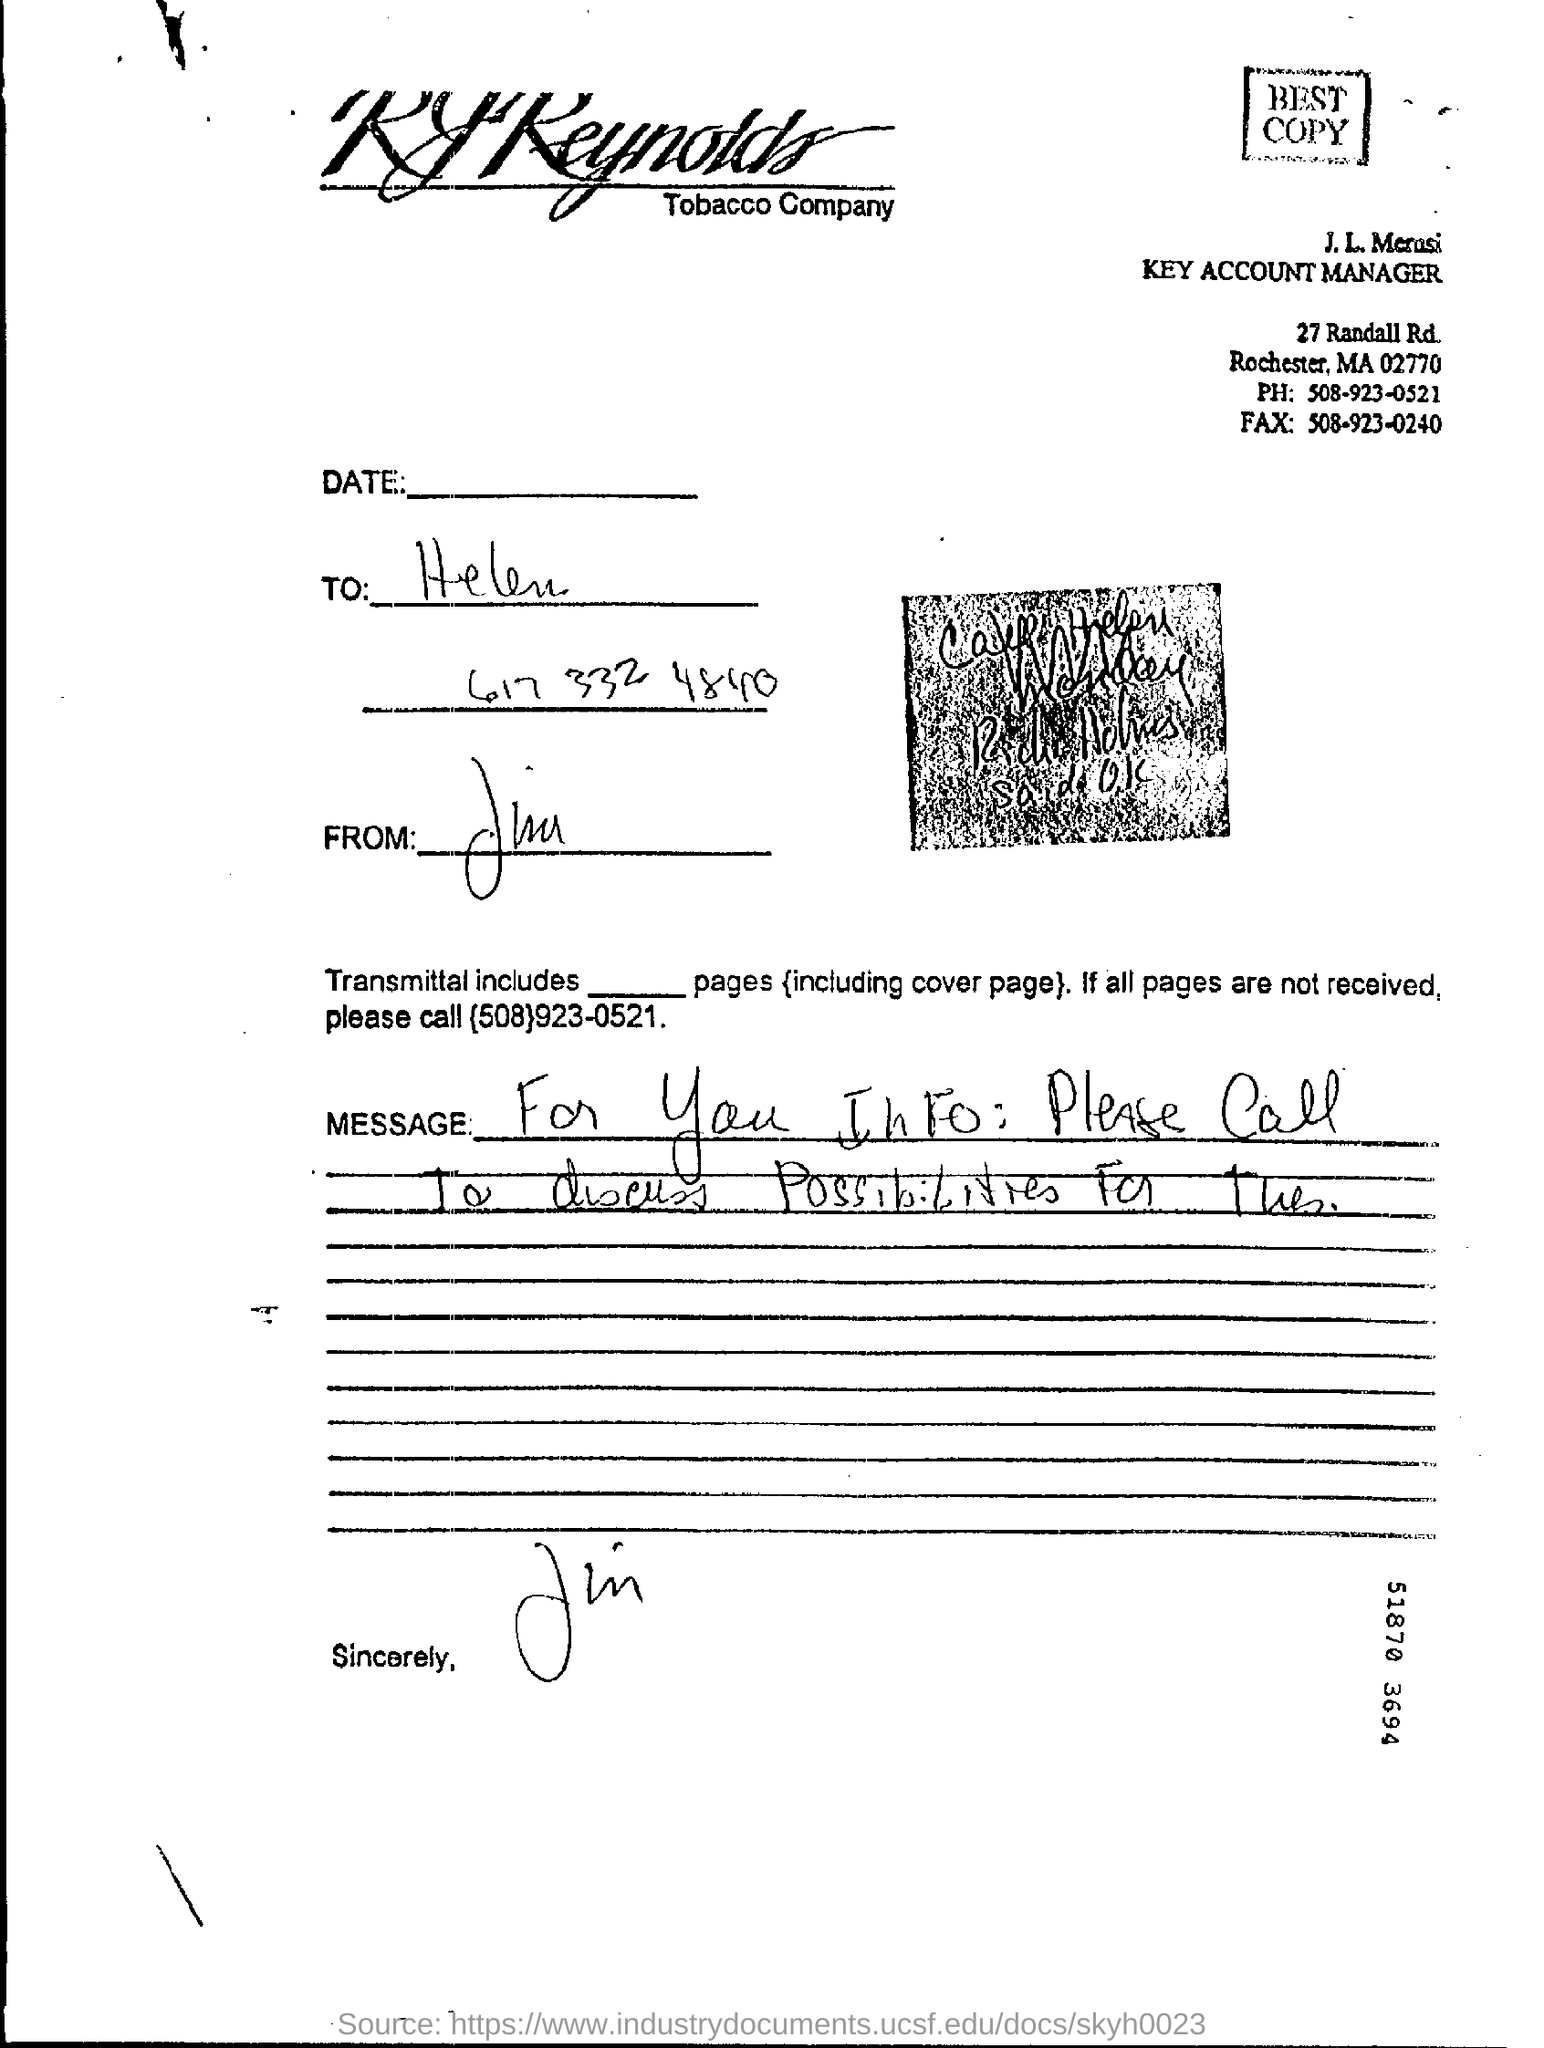What is the purpose of the message written in the letter? The message in the letter indicates it is informational, likely about business-related opportunities or updates. It instructs the recipient to call a specified phone number, suggesting a follow-up on a previous discussion or a prompt for initiating new business negotiations. 